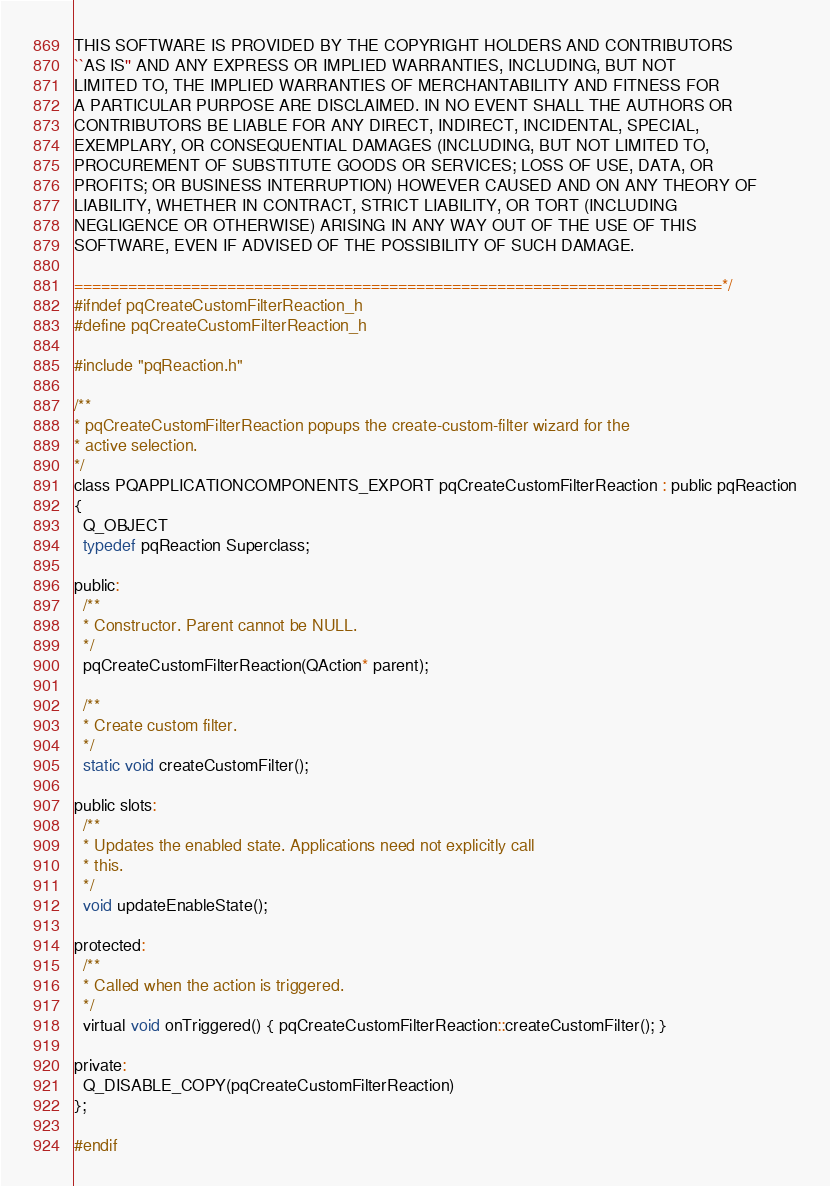Convert code to text. <code><loc_0><loc_0><loc_500><loc_500><_C_>
THIS SOFTWARE IS PROVIDED BY THE COPYRIGHT HOLDERS AND CONTRIBUTORS
``AS IS'' AND ANY EXPRESS OR IMPLIED WARRANTIES, INCLUDING, BUT NOT
LIMITED TO, THE IMPLIED WARRANTIES OF MERCHANTABILITY AND FITNESS FOR
A PARTICULAR PURPOSE ARE DISCLAIMED. IN NO EVENT SHALL THE AUTHORS OR
CONTRIBUTORS BE LIABLE FOR ANY DIRECT, INDIRECT, INCIDENTAL, SPECIAL,
EXEMPLARY, OR CONSEQUENTIAL DAMAGES (INCLUDING, BUT NOT LIMITED TO,
PROCUREMENT OF SUBSTITUTE GOODS OR SERVICES; LOSS OF USE, DATA, OR
PROFITS; OR BUSINESS INTERRUPTION) HOWEVER CAUSED AND ON ANY THEORY OF
LIABILITY, WHETHER IN CONTRACT, STRICT LIABILITY, OR TORT (INCLUDING
NEGLIGENCE OR OTHERWISE) ARISING IN ANY WAY OUT OF THE USE OF THIS
SOFTWARE, EVEN IF ADVISED OF THE POSSIBILITY OF SUCH DAMAGE.

========================================================================*/
#ifndef pqCreateCustomFilterReaction_h
#define pqCreateCustomFilterReaction_h

#include "pqReaction.h"

/**
* pqCreateCustomFilterReaction popups the create-custom-filter wizard for the
* active selection.
*/
class PQAPPLICATIONCOMPONENTS_EXPORT pqCreateCustomFilterReaction : public pqReaction
{
  Q_OBJECT
  typedef pqReaction Superclass;

public:
  /**
  * Constructor. Parent cannot be NULL.
  */
  pqCreateCustomFilterReaction(QAction* parent);

  /**
  * Create custom filter.
  */
  static void createCustomFilter();

public slots:
  /**
  * Updates the enabled state. Applications need not explicitly call
  * this.
  */
  void updateEnableState();

protected:
  /**
  * Called when the action is triggered.
  */
  virtual void onTriggered() { pqCreateCustomFilterReaction::createCustomFilter(); }

private:
  Q_DISABLE_COPY(pqCreateCustomFilterReaction)
};

#endif
</code> 